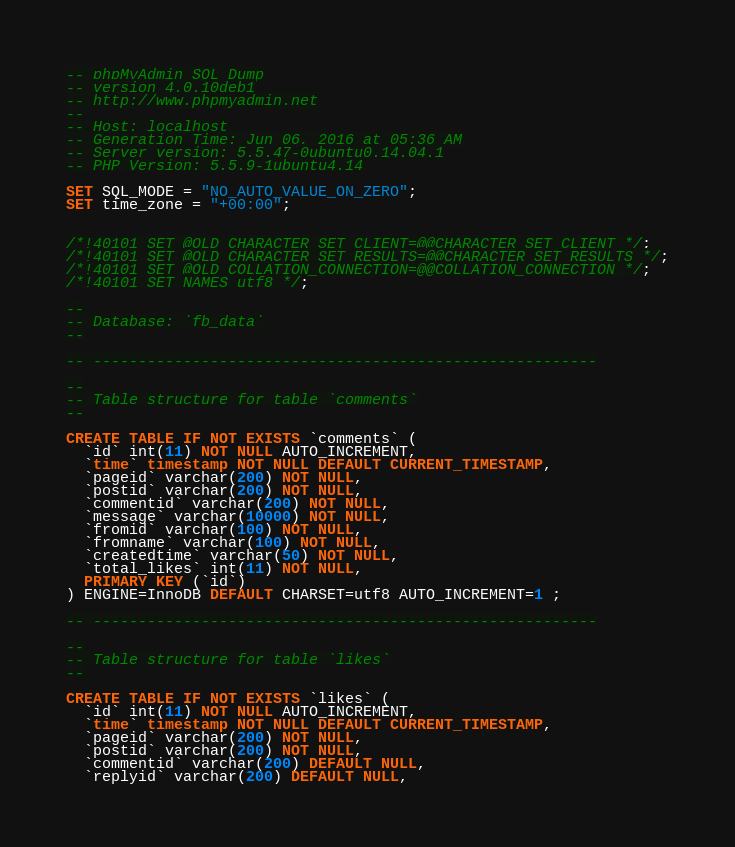Convert code to text. <code><loc_0><loc_0><loc_500><loc_500><_SQL_>-- phpMyAdmin SQL Dump
-- version 4.0.10deb1
-- http://www.phpmyadmin.net
--
-- Host: localhost
-- Generation Time: Jun 06, 2016 at 05:36 AM
-- Server version: 5.5.47-0ubuntu0.14.04.1
-- PHP Version: 5.5.9-1ubuntu4.14

SET SQL_MODE = "NO_AUTO_VALUE_ON_ZERO";
SET time_zone = "+00:00";


/*!40101 SET @OLD_CHARACTER_SET_CLIENT=@@CHARACTER_SET_CLIENT */;
/*!40101 SET @OLD_CHARACTER_SET_RESULTS=@@CHARACTER_SET_RESULTS */;
/*!40101 SET @OLD_COLLATION_CONNECTION=@@COLLATION_CONNECTION */;
/*!40101 SET NAMES utf8 */;

--
-- Database: `fb_data`
--

-- --------------------------------------------------------

--
-- Table structure for table `comments`
--

CREATE TABLE IF NOT EXISTS `comments` (
  `id` int(11) NOT NULL AUTO_INCREMENT,
  `time` timestamp NOT NULL DEFAULT CURRENT_TIMESTAMP,
  `pageid` varchar(200) NOT NULL,
  `postid` varchar(200) NOT NULL,
  `commentid` varchar(200) NOT NULL,
  `message` varchar(10000) NOT NULL,
  `fromid` varchar(100) NOT NULL,
  `fromname` varchar(100) NOT NULL,
  `createdtime` varchar(50) NOT NULL,
  `total_likes` int(11) NOT NULL,
  PRIMARY KEY (`id`)
) ENGINE=InnoDB DEFAULT CHARSET=utf8 AUTO_INCREMENT=1 ;

-- --------------------------------------------------------

--
-- Table structure for table `likes`
--

CREATE TABLE IF NOT EXISTS `likes` (
  `id` int(11) NOT NULL AUTO_INCREMENT,
  `time` timestamp NOT NULL DEFAULT CURRENT_TIMESTAMP,
  `pageid` varchar(200) NOT NULL,
  `postid` varchar(200) NOT NULL,
  `commentid` varchar(200) DEFAULT NULL,
  `replyid` varchar(200) DEFAULT NULL,</code> 